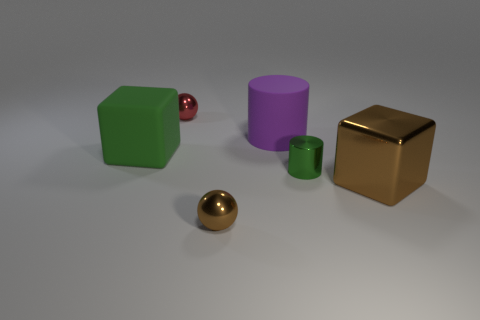Subtract all blue cylinders. Subtract all cyan cubes. How many cylinders are left? 2 Add 3 red shiny balls. How many objects exist? 9 Subtract all spheres. How many objects are left? 4 Add 6 small gray rubber blocks. How many small gray rubber blocks exist? 6 Subtract 1 brown blocks. How many objects are left? 5 Subtract all green things. Subtract all red matte cylinders. How many objects are left? 4 Add 3 big purple cylinders. How many big purple cylinders are left? 4 